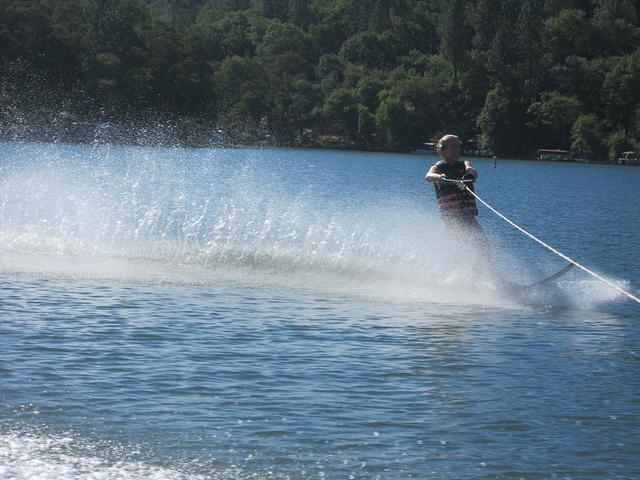What is on the other end of the rope?
Be succinct. Boat. What is on the water?
Answer briefly. Water skier. Is the person falling in the water?
Be succinct. No. What sport is the person performing?
Be succinct. Water skiing. 